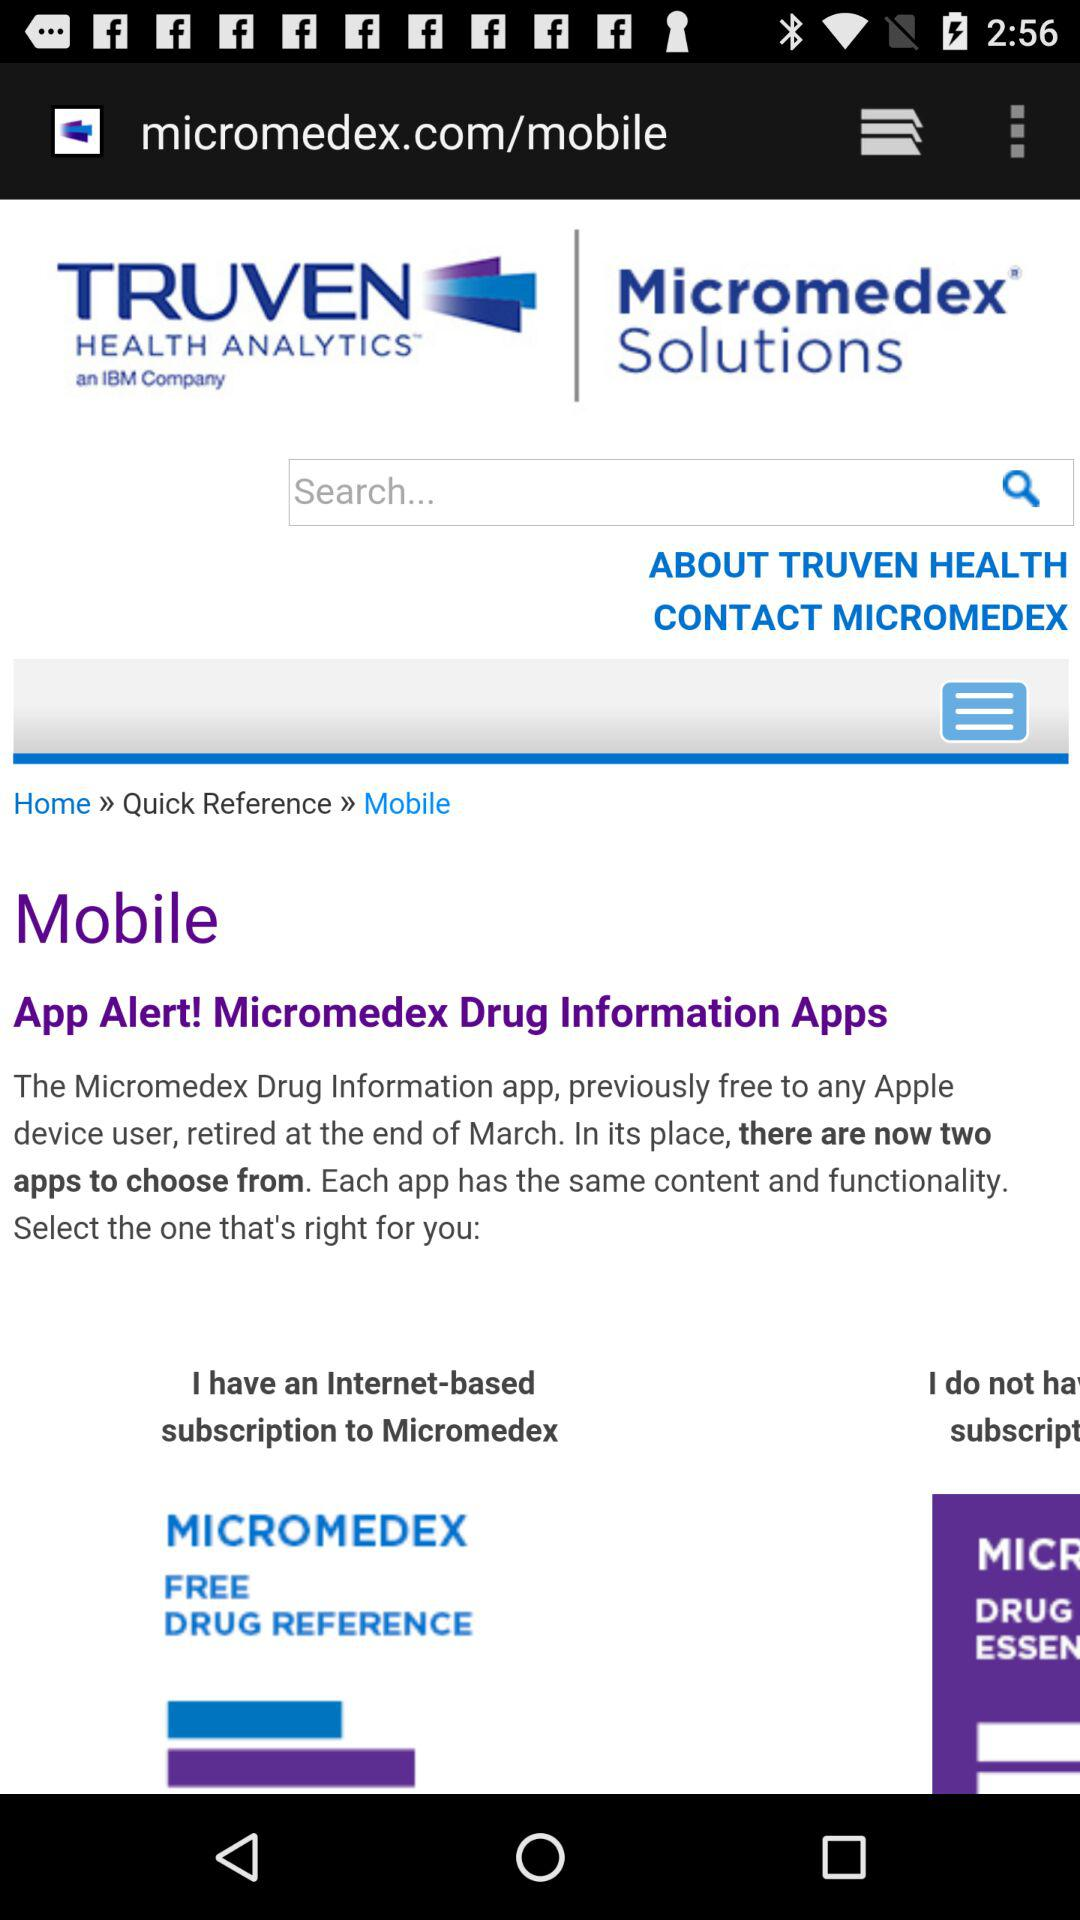How many applications are there in place of the "Micromedex Drug Information" application? There are 2 applications. 